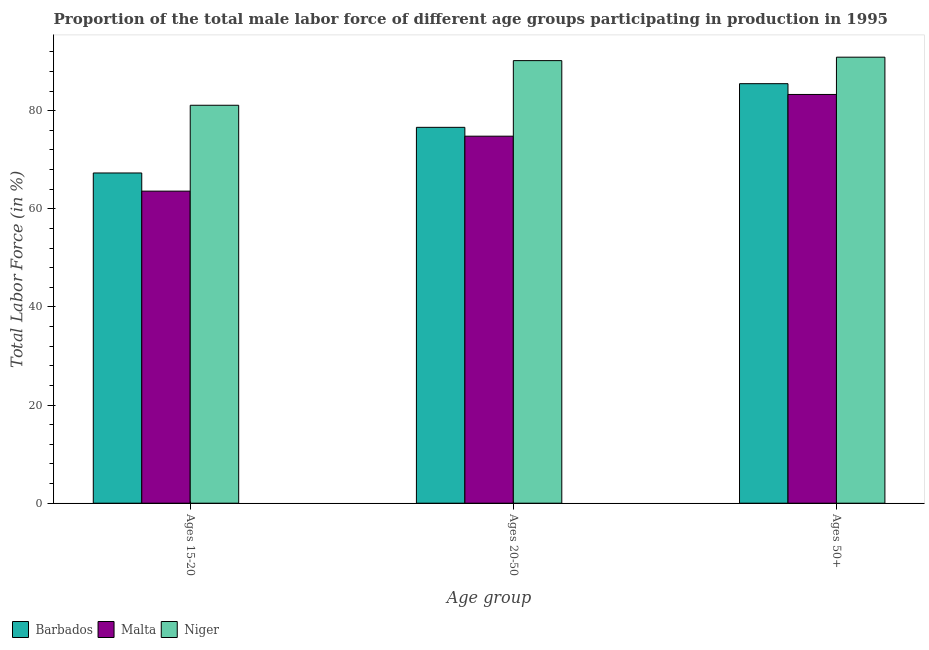How many different coloured bars are there?
Provide a short and direct response. 3. Are the number of bars per tick equal to the number of legend labels?
Offer a terse response. Yes. What is the label of the 3rd group of bars from the left?
Make the answer very short. Ages 50+. What is the percentage of male labor force within the age group 15-20 in Barbados?
Provide a succinct answer. 67.3. Across all countries, what is the maximum percentage of male labor force within the age group 20-50?
Provide a succinct answer. 90.2. Across all countries, what is the minimum percentage of male labor force within the age group 20-50?
Make the answer very short. 74.8. In which country was the percentage of male labor force within the age group 20-50 maximum?
Your answer should be very brief. Niger. In which country was the percentage of male labor force within the age group 20-50 minimum?
Your response must be concise. Malta. What is the total percentage of male labor force within the age group 20-50 in the graph?
Your response must be concise. 241.6. What is the difference between the percentage of male labor force within the age group 20-50 in Barbados and that in Niger?
Offer a very short reply. -13.6. What is the difference between the percentage of male labor force above age 50 in Malta and the percentage of male labor force within the age group 20-50 in Niger?
Keep it short and to the point. -6.9. What is the average percentage of male labor force above age 50 per country?
Give a very brief answer. 86.57. What is the difference between the percentage of male labor force within the age group 20-50 and percentage of male labor force above age 50 in Barbados?
Your answer should be compact. -8.9. What is the ratio of the percentage of male labor force within the age group 20-50 in Malta to that in Barbados?
Make the answer very short. 0.98. What is the difference between the highest and the second highest percentage of male labor force above age 50?
Give a very brief answer. 5.4. What is the difference between the highest and the lowest percentage of male labor force above age 50?
Make the answer very short. 7.6. In how many countries, is the percentage of male labor force within the age group 15-20 greater than the average percentage of male labor force within the age group 15-20 taken over all countries?
Your response must be concise. 1. Is the sum of the percentage of male labor force within the age group 20-50 in Barbados and Malta greater than the maximum percentage of male labor force within the age group 15-20 across all countries?
Your answer should be compact. Yes. What does the 3rd bar from the left in Ages 20-50 represents?
Provide a succinct answer. Niger. What does the 3rd bar from the right in Ages 20-50 represents?
Offer a very short reply. Barbados. Is it the case that in every country, the sum of the percentage of male labor force within the age group 15-20 and percentage of male labor force within the age group 20-50 is greater than the percentage of male labor force above age 50?
Keep it short and to the point. Yes. How many countries are there in the graph?
Offer a terse response. 3. What is the difference between two consecutive major ticks on the Y-axis?
Offer a terse response. 20. Does the graph contain any zero values?
Your answer should be compact. No. Does the graph contain grids?
Keep it short and to the point. No. How many legend labels are there?
Offer a terse response. 3. How are the legend labels stacked?
Provide a short and direct response. Horizontal. What is the title of the graph?
Offer a terse response. Proportion of the total male labor force of different age groups participating in production in 1995. Does "Tanzania" appear as one of the legend labels in the graph?
Provide a short and direct response. No. What is the label or title of the X-axis?
Your answer should be very brief. Age group. What is the Total Labor Force (in %) in Barbados in Ages 15-20?
Provide a succinct answer. 67.3. What is the Total Labor Force (in %) in Malta in Ages 15-20?
Your answer should be very brief. 63.6. What is the Total Labor Force (in %) of Niger in Ages 15-20?
Your response must be concise. 81.1. What is the Total Labor Force (in %) in Barbados in Ages 20-50?
Provide a succinct answer. 76.6. What is the Total Labor Force (in %) in Malta in Ages 20-50?
Give a very brief answer. 74.8. What is the Total Labor Force (in %) in Niger in Ages 20-50?
Your response must be concise. 90.2. What is the Total Labor Force (in %) in Barbados in Ages 50+?
Provide a short and direct response. 85.5. What is the Total Labor Force (in %) in Malta in Ages 50+?
Make the answer very short. 83.3. What is the Total Labor Force (in %) in Niger in Ages 50+?
Provide a short and direct response. 90.9. Across all Age group, what is the maximum Total Labor Force (in %) of Barbados?
Your answer should be compact. 85.5. Across all Age group, what is the maximum Total Labor Force (in %) of Malta?
Offer a very short reply. 83.3. Across all Age group, what is the maximum Total Labor Force (in %) of Niger?
Provide a short and direct response. 90.9. Across all Age group, what is the minimum Total Labor Force (in %) in Barbados?
Your answer should be very brief. 67.3. Across all Age group, what is the minimum Total Labor Force (in %) in Malta?
Offer a very short reply. 63.6. Across all Age group, what is the minimum Total Labor Force (in %) of Niger?
Offer a terse response. 81.1. What is the total Total Labor Force (in %) of Barbados in the graph?
Your response must be concise. 229.4. What is the total Total Labor Force (in %) in Malta in the graph?
Provide a short and direct response. 221.7. What is the total Total Labor Force (in %) of Niger in the graph?
Provide a short and direct response. 262.2. What is the difference between the Total Labor Force (in %) in Barbados in Ages 15-20 and that in Ages 20-50?
Your answer should be very brief. -9.3. What is the difference between the Total Labor Force (in %) in Barbados in Ages 15-20 and that in Ages 50+?
Your answer should be compact. -18.2. What is the difference between the Total Labor Force (in %) of Malta in Ages 15-20 and that in Ages 50+?
Keep it short and to the point. -19.7. What is the difference between the Total Labor Force (in %) in Malta in Ages 20-50 and that in Ages 50+?
Provide a short and direct response. -8.5. What is the difference between the Total Labor Force (in %) of Niger in Ages 20-50 and that in Ages 50+?
Your answer should be very brief. -0.7. What is the difference between the Total Labor Force (in %) of Barbados in Ages 15-20 and the Total Labor Force (in %) of Niger in Ages 20-50?
Provide a succinct answer. -22.9. What is the difference between the Total Labor Force (in %) of Malta in Ages 15-20 and the Total Labor Force (in %) of Niger in Ages 20-50?
Provide a succinct answer. -26.6. What is the difference between the Total Labor Force (in %) of Barbados in Ages 15-20 and the Total Labor Force (in %) of Malta in Ages 50+?
Your response must be concise. -16. What is the difference between the Total Labor Force (in %) of Barbados in Ages 15-20 and the Total Labor Force (in %) of Niger in Ages 50+?
Give a very brief answer. -23.6. What is the difference between the Total Labor Force (in %) of Malta in Ages 15-20 and the Total Labor Force (in %) of Niger in Ages 50+?
Provide a succinct answer. -27.3. What is the difference between the Total Labor Force (in %) of Barbados in Ages 20-50 and the Total Labor Force (in %) of Niger in Ages 50+?
Your answer should be compact. -14.3. What is the difference between the Total Labor Force (in %) of Malta in Ages 20-50 and the Total Labor Force (in %) of Niger in Ages 50+?
Provide a succinct answer. -16.1. What is the average Total Labor Force (in %) of Barbados per Age group?
Make the answer very short. 76.47. What is the average Total Labor Force (in %) of Malta per Age group?
Offer a terse response. 73.9. What is the average Total Labor Force (in %) of Niger per Age group?
Give a very brief answer. 87.4. What is the difference between the Total Labor Force (in %) in Barbados and Total Labor Force (in %) in Malta in Ages 15-20?
Provide a short and direct response. 3.7. What is the difference between the Total Labor Force (in %) in Barbados and Total Labor Force (in %) in Niger in Ages 15-20?
Your answer should be compact. -13.8. What is the difference between the Total Labor Force (in %) of Malta and Total Labor Force (in %) of Niger in Ages 15-20?
Your answer should be very brief. -17.5. What is the difference between the Total Labor Force (in %) in Malta and Total Labor Force (in %) in Niger in Ages 20-50?
Offer a very short reply. -15.4. What is the difference between the Total Labor Force (in %) of Barbados and Total Labor Force (in %) of Malta in Ages 50+?
Keep it short and to the point. 2.2. What is the difference between the Total Labor Force (in %) of Malta and Total Labor Force (in %) of Niger in Ages 50+?
Make the answer very short. -7.6. What is the ratio of the Total Labor Force (in %) of Barbados in Ages 15-20 to that in Ages 20-50?
Offer a terse response. 0.88. What is the ratio of the Total Labor Force (in %) in Malta in Ages 15-20 to that in Ages 20-50?
Provide a succinct answer. 0.85. What is the ratio of the Total Labor Force (in %) in Niger in Ages 15-20 to that in Ages 20-50?
Provide a succinct answer. 0.9. What is the ratio of the Total Labor Force (in %) of Barbados in Ages 15-20 to that in Ages 50+?
Offer a terse response. 0.79. What is the ratio of the Total Labor Force (in %) of Malta in Ages 15-20 to that in Ages 50+?
Offer a very short reply. 0.76. What is the ratio of the Total Labor Force (in %) of Niger in Ages 15-20 to that in Ages 50+?
Provide a succinct answer. 0.89. What is the ratio of the Total Labor Force (in %) in Barbados in Ages 20-50 to that in Ages 50+?
Offer a terse response. 0.9. What is the ratio of the Total Labor Force (in %) in Malta in Ages 20-50 to that in Ages 50+?
Your answer should be compact. 0.9. What is the difference between the highest and the second highest Total Labor Force (in %) in Malta?
Provide a short and direct response. 8.5. What is the difference between the highest and the lowest Total Labor Force (in %) in Niger?
Provide a short and direct response. 9.8. 